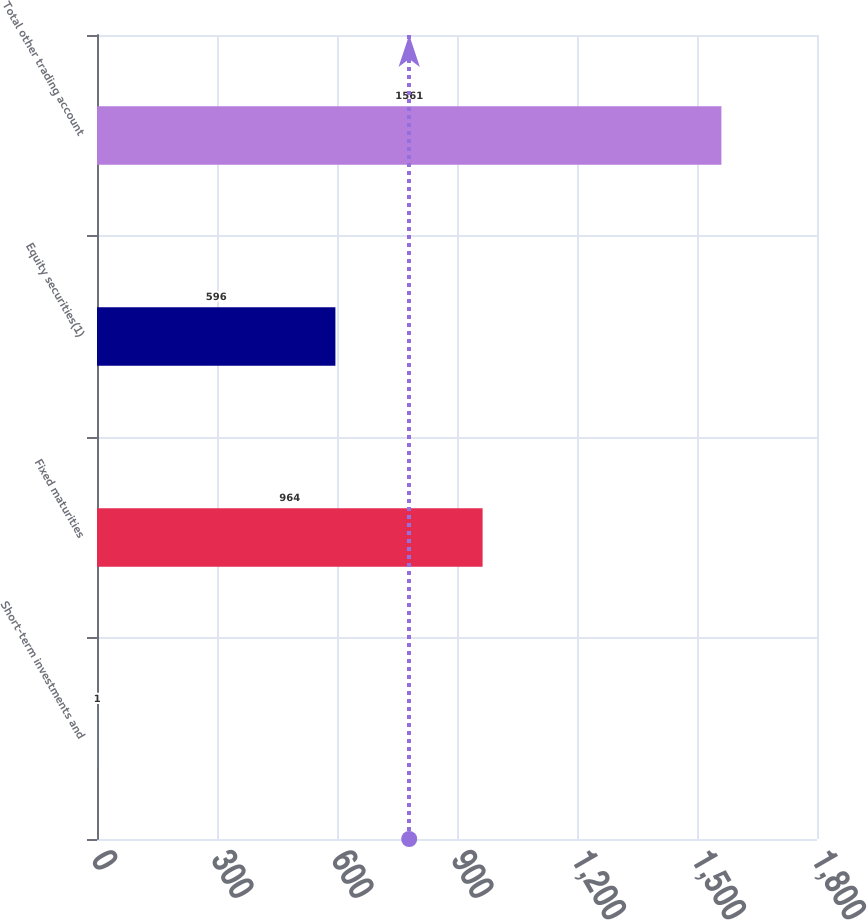Convert chart. <chart><loc_0><loc_0><loc_500><loc_500><bar_chart><fcel>Short-term investments and<fcel>Fixed maturities<fcel>Equity securities(1)<fcel>Total other trading account<nl><fcel>1<fcel>964<fcel>596<fcel>1561<nl></chart> 